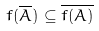Convert formula to latex. <formula><loc_0><loc_0><loc_500><loc_500>f ( \overline { A } ) \subseteq \overline { f ( A ) }</formula> 